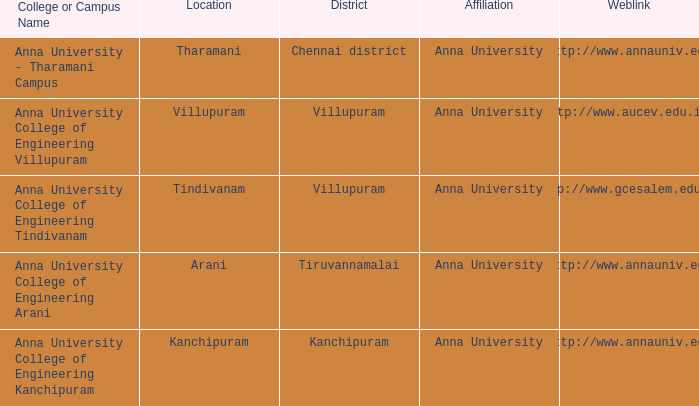What District has a Location of tharamani? Chennai district. 